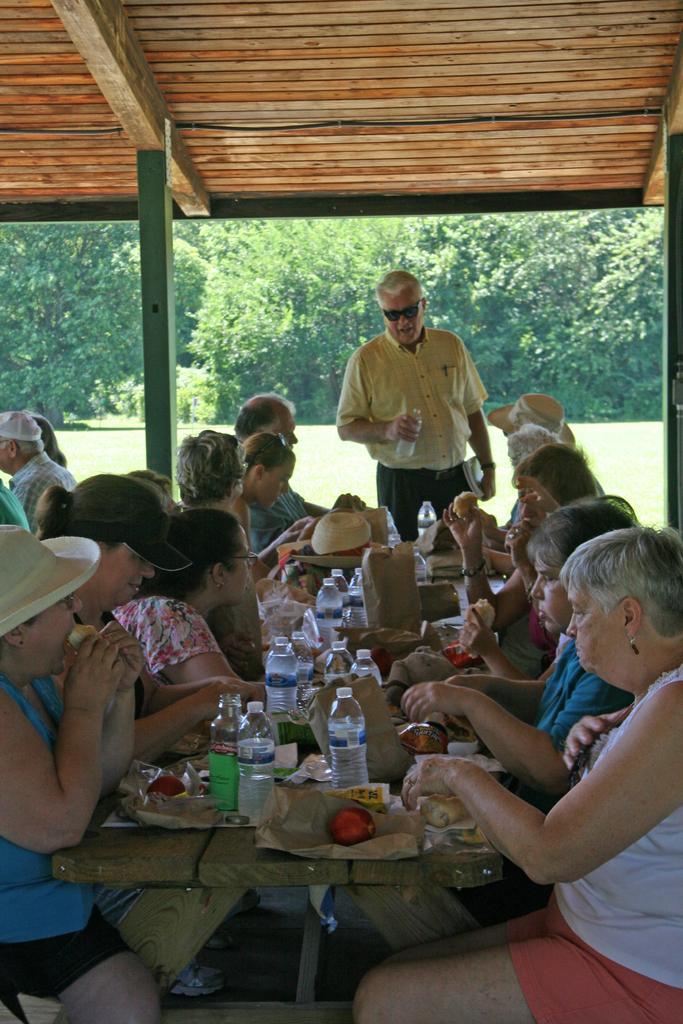How would you summarize this image in a sentence or two? In the middle of the image a man is standing and holding a bottle. Bottom of the image few people are sitting surrounding the table. On the table there are some bottles, hats and there are some food products and fruits. Top of the image there is a roof. 